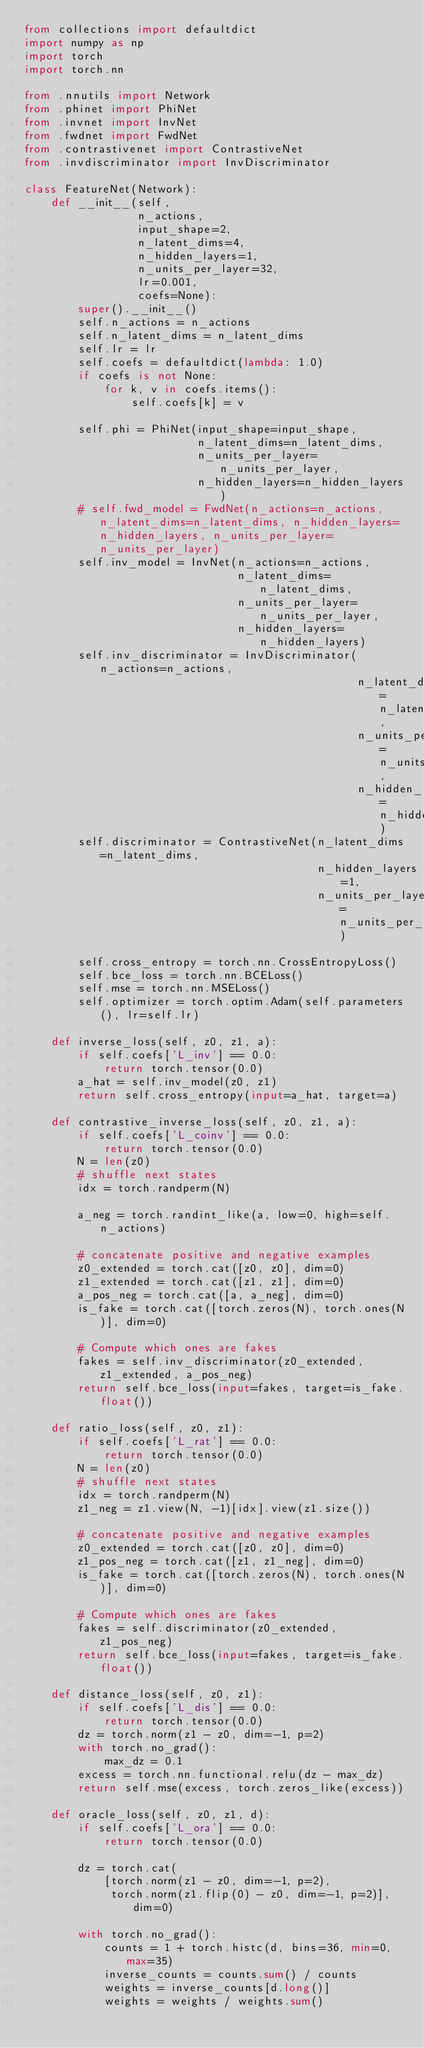<code> <loc_0><loc_0><loc_500><loc_500><_Python_>from collections import defaultdict
import numpy as np
import torch
import torch.nn

from .nnutils import Network
from .phinet import PhiNet
from .invnet import InvNet
from .fwdnet import FwdNet
from .contrastivenet import ContrastiveNet
from .invdiscriminator import InvDiscriminator

class FeatureNet(Network):
    def __init__(self,
                 n_actions,
                 input_shape=2,
                 n_latent_dims=4,
                 n_hidden_layers=1,
                 n_units_per_layer=32,
                 lr=0.001,
                 coefs=None):
        super().__init__()
        self.n_actions = n_actions
        self.n_latent_dims = n_latent_dims
        self.lr = lr
        self.coefs = defaultdict(lambda: 1.0)
        if coefs is not None:
            for k, v in coefs.items():
                self.coefs[k] = v

        self.phi = PhiNet(input_shape=input_shape,
                          n_latent_dims=n_latent_dims,
                          n_units_per_layer=n_units_per_layer,
                          n_hidden_layers=n_hidden_layers)
        # self.fwd_model = FwdNet(n_actions=n_actions, n_latent_dims=n_latent_dims, n_hidden_layers=n_hidden_layers, n_units_per_layer=n_units_per_layer)
        self.inv_model = InvNet(n_actions=n_actions,
                                n_latent_dims=n_latent_dims,
                                n_units_per_layer=n_units_per_layer,
                                n_hidden_layers=n_hidden_layers)
        self.inv_discriminator = InvDiscriminator(n_actions=n_actions,
                                                  n_latent_dims=n_latent_dims,
                                                  n_units_per_layer=n_units_per_layer,
                                                  n_hidden_layers=n_hidden_layers)
        self.discriminator = ContrastiveNet(n_latent_dims=n_latent_dims,
                                            n_hidden_layers=1,
                                            n_units_per_layer=n_units_per_layer)

        self.cross_entropy = torch.nn.CrossEntropyLoss()
        self.bce_loss = torch.nn.BCELoss()
        self.mse = torch.nn.MSELoss()
        self.optimizer = torch.optim.Adam(self.parameters(), lr=self.lr)

    def inverse_loss(self, z0, z1, a):
        if self.coefs['L_inv'] == 0.0:
            return torch.tensor(0.0)
        a_hat = self.inv_model(z0, z1)
        return self.cross_entropy(input=a_hat, target=a)

    def contrastive_inverse_loss(self, z0, z1, a):
        if self.coefs['L_coinv'] == 0.0:
            return torch.tensor(0.0)
        N = len(z0)
        # shuffle next states
        idx = torch.randperm(N)

        a_neg = torch.randint_like(a, low=0, high=self.n_actions)

        # concatenate positive and negative examples
        z0_extended = torch.cat([z0, z0], dim=0)
        z1_extended = torch.cat([z1, z1], dim=0)
        a_pos_neg = torch.cat([a, a_neg], dim=0)
        is_fake = torch.cat([torch.zeros(N), torch.ones(N)], dim=0)

        # Compute which ones are fakes
        fakes = self.inv_discriminator(z0_extended, z1_extended, a_pos_neg)
        return self.bce_loss(input=fakes, target=is_fake.float())

    def ratio_loss(self, z0, z1):
        if self.coefs['L_rat'] == 0.0:
            return torch.tensor(0.0)
        N = len(z0)
        # shuffle next states
        idx = torch.randperm(N)
        z1_neg = z1.view(N, -1)[idx].view(z1.size())

        # concatenate positive and negative examples
        z0_extended = torch.cat([z0, z0], dim=0)
        z1_pos_neg = torch.cat([z1, z1_neg], dim=0)
        is_fake = torch.cat([torch.zeros(N), torch.ones(N)], dim=0)

        # Compute which ones are fakes
        fakes = self.discriminator(z0_extended, z1_pos_neg)
        return self.bce_loss(input=fakes, target=is_fake.float())

    def distance_loss(self, z0, z1):
        if self.coefs['L_dis'] == 0.0:
            return torch.tensor(0.0)
        dz = torch.norm(z1 - z0, dim=-1, p=2)
        with torch.no_grad():
            max_dz = 0.1
        excess = torch.nn.functional.relu(dz - max_dz)
        return self.mse(excess, torch.zeros_like(excess))

    def oracle_loss(self, z0, z1, d):
        if self.coefs['L_ora'] == 0.0:
            return torch.tensor(0.0)

        dz = torch.cat(
            [torch.norm(z1 - z0, dim=-1, p=2),
             torch.norm(z1.flip(0) - z0, dim=-1, p=2)], dim=0)

        with torch.no_grad():
            counts = 1 + torch.histc(d, bins=36, min=0, max=35)
            inverse_counts = counts.sum() / counts
            weights = inverse_counts[d.long()]
            weights = weights / weights.sum()
</code> 